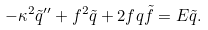Convert formula to latex. <formula><loc_0><loc_0><loc_500><loc_500>- \kappa ^ { 2 } \tilde { q } ^ { \prime \prime } + f ^ { 2 } \tilde { q } + 2 f q \tilde { f } = E \tilde { q } .</formula> 